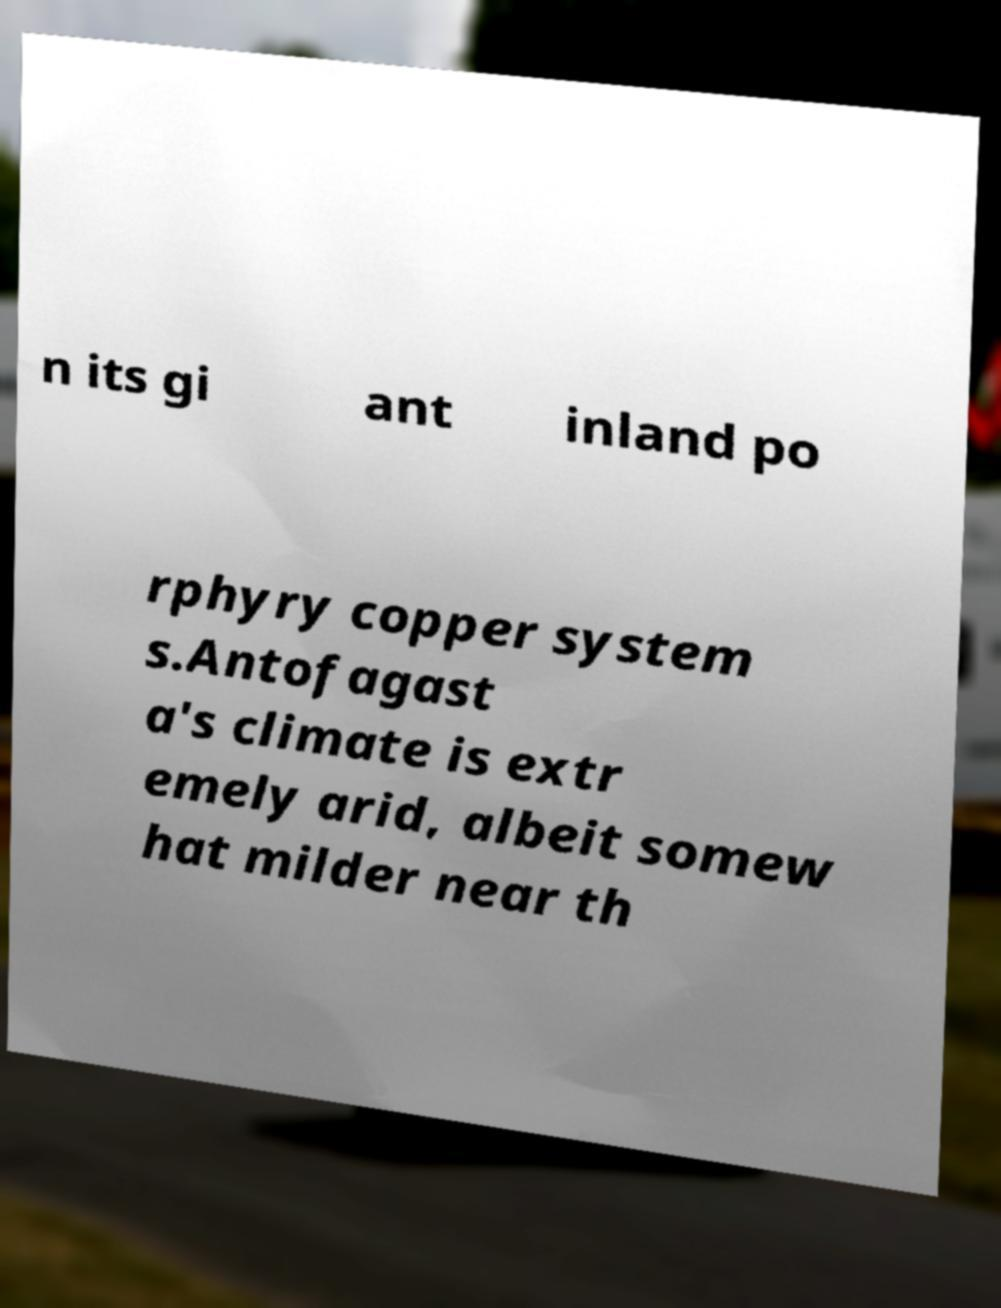Can you read and provide the text displayed in the image?This photo seems to have some interesting text. Can you extract and type it out for me? n its gi ant inland po rphyry copper system s.Antofagast a's climate is extr emely arid, albeit somew hat milder near th 